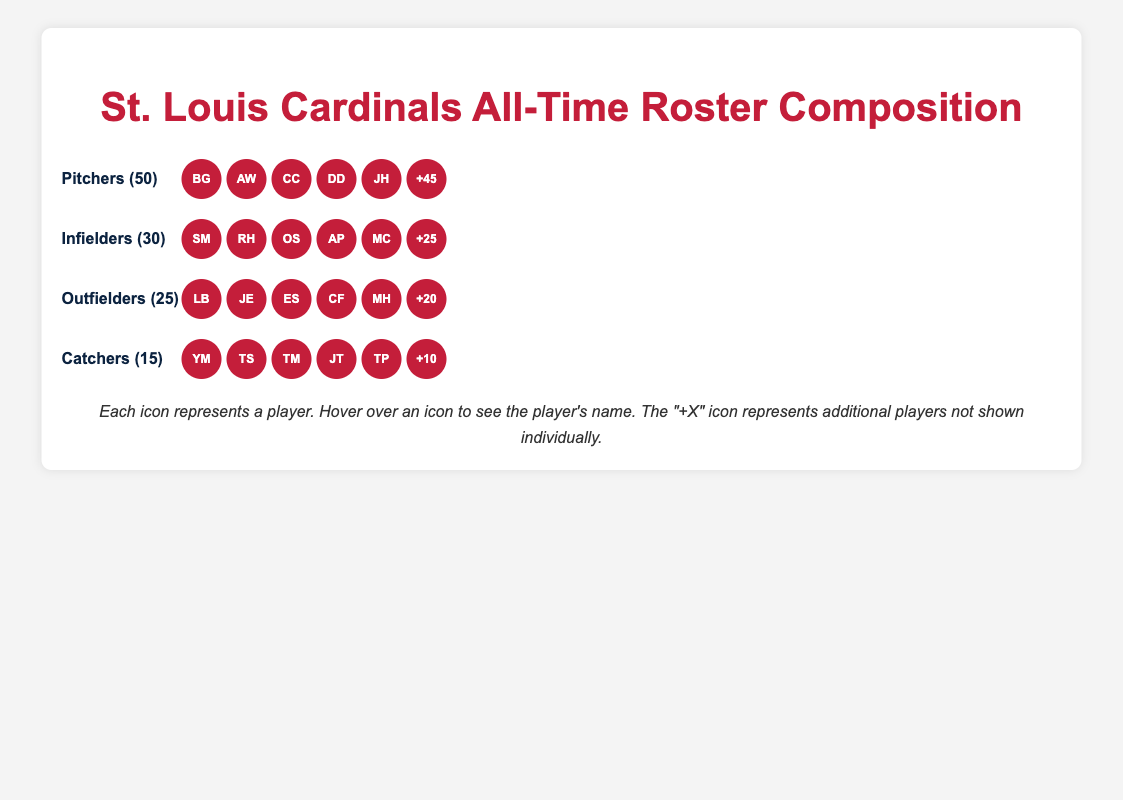What's the title of the figure? The title is prominently displayed at the top of the figure in a larger, bold font. It reads "St. Louis Cardinals All-Time Roster Composition."
Answer: St. Louis Cardinals All-Time Roster Composition How many positions are represented in the figure? Counting the different sections labeled with position names in the Isotype Plot, we see four positions: Pitchers, Infielders, Outfielders, and Catchers.
Answer: 4 Which position has the highest count of players? By comparing the numbers in parentheses next to each position name, we see that Pitchers have the highest count with 50 players.
Answer: Pitchers How many more pitchers are there than catchers? There are 50 pitchers and 15 catchers. The difference between the two counts is 50 - 15.
Answer: 35 Name two players from the outfielders' list. In the Outfielders section, there are icons with initials representing: Lou Brock (LB) and Jim Edmonds (JE).
Answer: Lou Brock and Jim Edmonds Which position has the fewest number of players? By comparing the numbers in parentheses, we see that the position with the fewest players is Catchers, with 15 players.
Answer: Catchers Who is one of the iconic players in the catchers' list? In the Catchers section, one of the initials displayed is YM, which stands for Yadier Molina.
Answer: Yadier Molina How many more infielders and outfielders combined are there than catchers? The number of infielders is 30 and the number of outfielders is 25. Combining the two gives 30 + 25. The number of catchers is 15. The difference is (30 + 25) - 15.
Answer: 40 What is the total number of players represented in the Isotype Plot? Adding up the numbers for each position: 50 (Pitchers) + 30 (Infielders) + 25 (Outfielders) + 15 (Catchers) = 120.
Answer: 120 Name three positions that have some specific iconic players highlighted. Looking through the initial icons provided, Pitchers, Infielders, and Outfielders all have specific highlighted players.
Answer: Pitchers, Infielders, Outfielders 